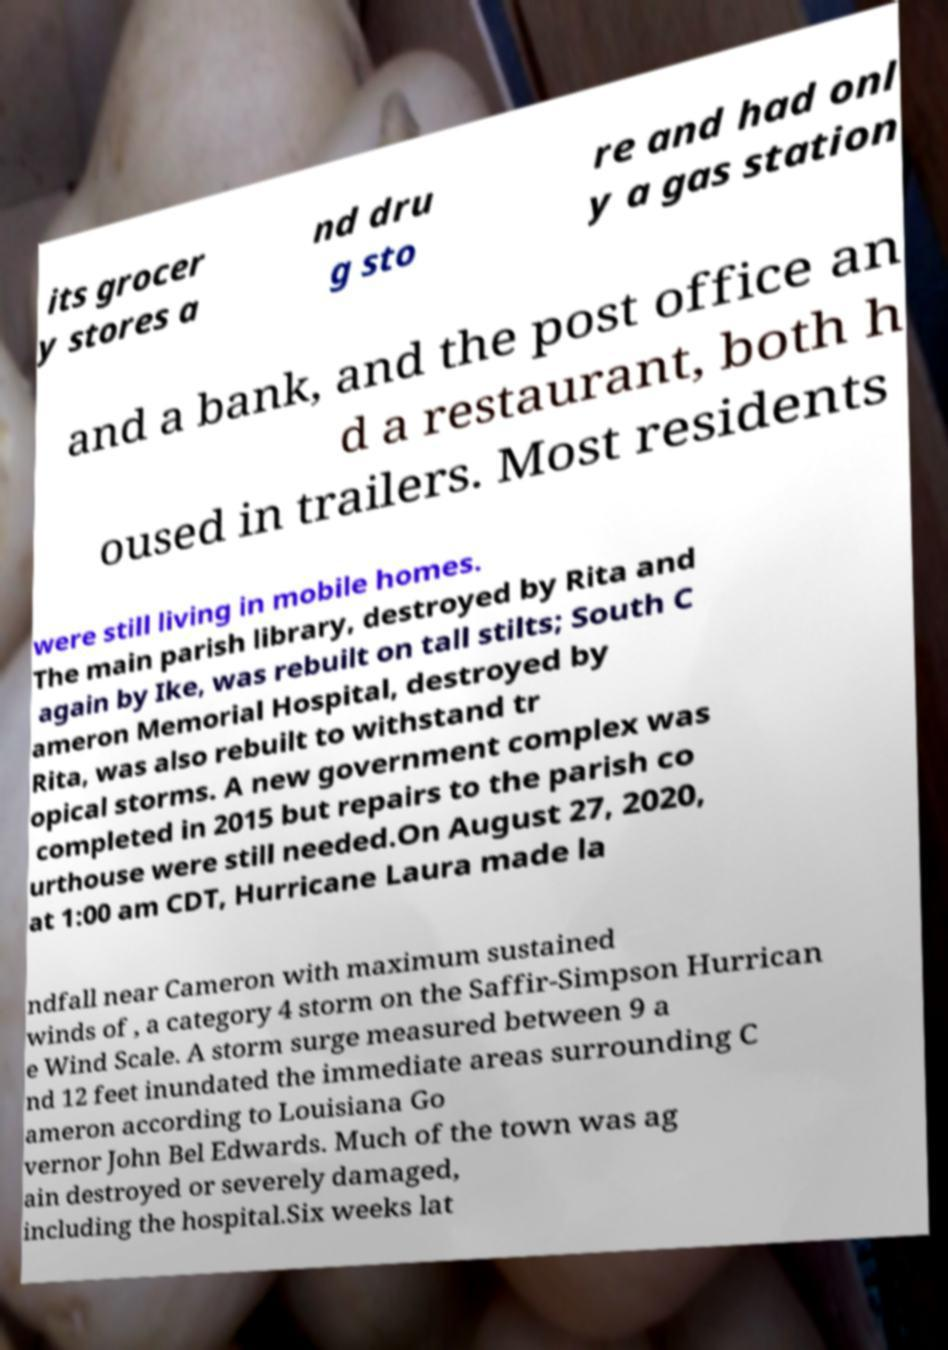What messages or text are displayed in this image? I need them in a readable, typed format. its grocer y stores a nd dru g sto re and had onl y a gas station and a bank, and the post office an d a restaurant, both h oused in trailers. Most residents were still living in mobile homes. The main parish library, destroyed by Rita and again by Ike, was rebuilt on tall stilts; South C ameron Memorial Hospital, destroyed by Rita, was also rebuilt to withstand tr opical storms. A new government complex was completed in 2015 but repairs to the parish co urthouse were still needed.On August 27, 2020, at 1:00 am CDT, Hurricane Laura made la ndfall near Cameron with maximum sustained winds of , a category 4 storm on the Saffir-Simpson Hurrican e Wind Scale. A storm surge measured between 9 a nd 12 feet inundated the immediate areas surrounding C ameron according to Louisiana Go vernor John Bel Edwards. Much of the town was ag ain destroyed or severely damaged, including the hospital.Six weeks lat 